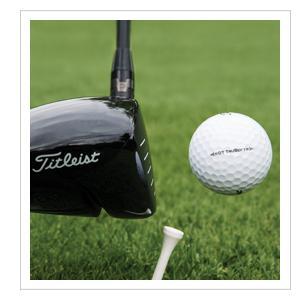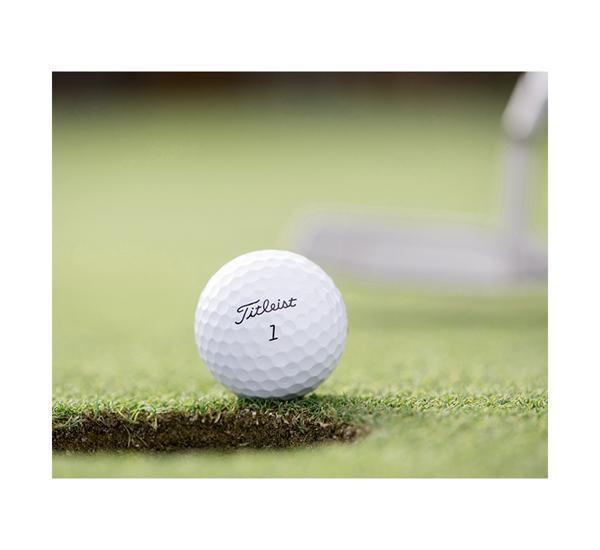The first image is the image on the left, the second image is the image on the right. For the images shown, is this caption "A golf ball is near a black golf club" true? Answer yes or no. Yes. 